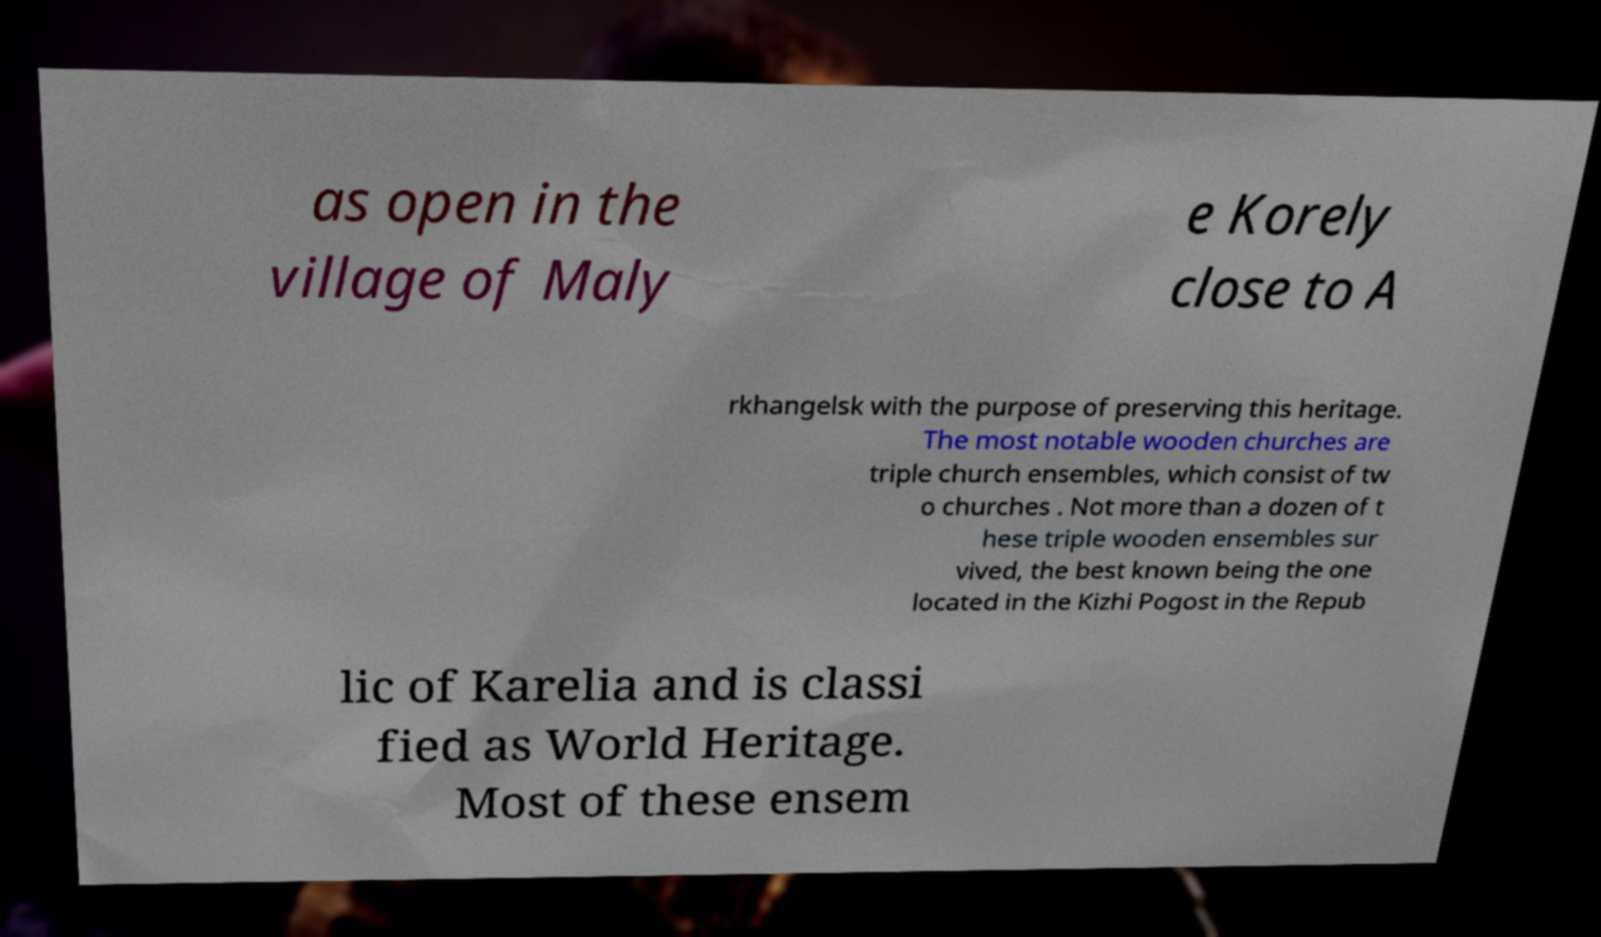For documentation purposes, I need the text within this image transcribed. Could you provide that? as open in the village of Maly e Korely close to A rkhangelsk with the purpose of preserving this heritage. The most notable wooden churches are triple church ensembles, which consist of tw o churches . Not more than a dozen of t hese triple wooden ensembles sur vived, the best known being the one located in the Kizhi Pogost in the Repub lic of Karelia and is classi fied as World Heritage. Most of these ensem 